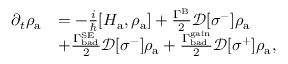<formula> <loc_0><loc_0><loc_500><loc_500>\begin{array} { r l } { \partial _ { t } \rho _ { a } } & { = - \frac { i } { } [ H _ { a } , \rho _ { a } ] + \frac { \Gamma ^ { B } } { 2 } \mathcal { D } [ \sigma ^ { - } ] \rho _ { a } } \\ & { + \frac { \Gamma _ { b a d } ^ { S E } } { 2 } \mathcal { D } [ \sigma ^ { - } ] \rho _ { a } + \frac { \Gamma _ { b a d } ^ { g a i n } } { 2 } \mathcal { D } [ \sigma ^ { + } ] \rho _ { a } , } \end{array}</formula> 